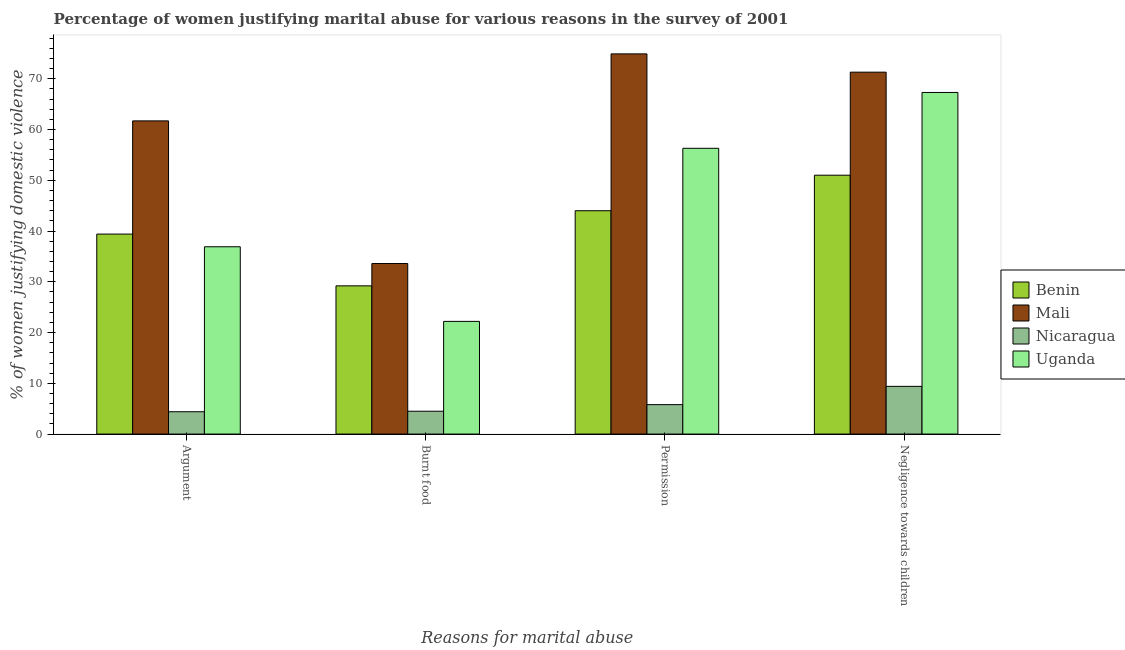How many different coloured bars are there?
Your response must be concise. 4. Are the number of bars on each tick of the X-axis equal?
Your response must be concise. Yes. How many bars are there on the 1st tick from the left?
Keep it short and to the point. 4. How many bars are there on the 4th tick from the right?
Offer a terse response. 4. What is the label of the 4th group of bars from the left?
Your answer should be very brief. Negligence towards children. Across all countries, what is the maximum percentage of women justifying abuse in the case of an argument?
Keep it short and to the point. 61.7. Across all countries, what is the minimum percentage of women justifying abuse for going without permission?
Give a very brief answer. 5.8. In which country was the percentage of women justifying abuse for burning food maximum?
Make the answer very short. Mali. In which country was the percentage of women justifying abuse for burning food minimum?
Ensure brevity in your answer.  Nicaragua. What is the total percentage of women justifying abuse in the case of an argument in the graph?
Give a very brief answer. 142.4. What is the difference between the percentage of women justifying abuse for going without permission in Mali and the percentage of women justifying abuse for showing negligence towards children in Nicaragua?
Your answer should be compact. 65.5. What is the average percentage of women justifying abuse for showing negligence towards children per country?
Keep it short and to the point. 49.75. What is the difference between the percentage of women justifying abuse for going without permission and percentage of women justifying abuse in the case of an argument in Uganda?
Your answer should be compact. 19.4. What is the ratio of the percentage of women justifying abuse for burning food in Uganda to that in Benin?
Offer a very short reply. 0.76. Is the percentage of women justifying abuse in the case of an argument in Benin less than that in Nicaragua?
Offer a very short reply. No. What is the difference between the highest and the second highest percentage of women justifying abuse for going without permission?
Your answer should be compact. 18.6. What is the difference between the highest and the lowest percentage of women justifying abuse for showing negligence towards children?
Provide a succinct answer. 61.9. Is it the case that in every country, the sum of the percentage of women justifying abuse for going without permission and percentage of women justifying abuse for showing negligence towards children is greater than the sum of percentage of women justifying abuse in the case of an argument and percentage of women justifying abuse for burning food?
Provide a short and direct response. No. What does the 3rd bar from the left in Permission represents?
Your response must be concise. Nicaragua. What does the 1st bar from the right in Argument represents?
Keep it short and to the point. Uganda. Is it the case that in every country, the sum of the percentage of women justifying abuse in the case of an argument and percentage of women justifying abuse for burning food is greater than the percentage of women justifying abuse for going without permission?
Provide a succinct answer. Yes. Are all the bars in the graph horizontal?
Make the answer very short. No. Are the values on the major ticks of Y-axis written in scientific E-notation?
Provide a succinct answer. No. How are the legend labels stacked?
Give a very brief answer. Vertical. What is the title of the graph?
Offer a terse response. Percentage of women justifying marital abuse for various reasons in the survey of 2001. What is the label or title of the X-axis?
Your response must be concise. Reasons for marital abuse. What is the label or title of the Y-axis?
Provide a short and direct response. % of women justifying domestic violence. What is the % of women justifying domestic violence of Benin in Argument?
Provide a succinct answer. 39.4. What is the % of women justifying domestic violence of Mali in Argument?
Your answer should be compact. 61.7. What is the % of women justifying domestic violence of Uganda in Argument?
Offer a terse response. 36.9. What is the % of women justifying domestic violence in Benin in Burnt food?
Your answer should be very brief. 29.2. What is the % of women justifying domestic violence of Mali in Burnt food?
Your answer should be very brief. 33.6. What is the % of women justifying domestic violence in Uganda in Burnt food?
Your answer should be very brief. 22.2. What is the % of women justifying domestic violence of Mali in Permission?
Your response must be concise. 74.9. What is the % of women justifying domestic violence in Uganda in Permission?
Ensure brevity in your answer.  56.3. What is the % of women justifying domestic violence in Benin in Negligence towards children?
Provide a succinct answer. 51. What is the % of women justifying domestic violence in Mali in Negligence towards children?
Offer a terse response. 71.3. What is the % of women justifying domestic violence in Nicaragua in Negligence towards children?
Offer a terse response. 9.4. What is the % of women justifying domestic violence in Uganda in Negligence towards children?
Your answer should be very brief. 67.3. Across all Reasons for marital abuse, what is the maximum % of women justifying domestic violence of Mali?
Offer a very short reply. 74.9. Across all Reasons for marital abuse, what is the maximum % of women justifying domestic violence in Uganda?
Provide a short and direct response. 67.3. Across all Reasons for marital abuse, what is the minimum % of women justifying domestic violence of Benin?
Your answer should be compact. 29.2. Across all Reasons for marital abuse, what is the minimum % of women justifying domestic violence in Mali?
Ensure brevity in your answer.  33.6. Across all Reasons for marital abuse, what is the minimum % of women justifying domestic violence in Uganda?
Provide a short and direct response. 22.2. What is the total % of women justifying domestic violence in Benin in the graph?
Provide a succinct answer. 163.6. What is the total % of women justifying domestic violence in Mali in the graph?
Offer a terse response. 241.5. What is the total % of women justifying domestic violence in Nicaragua in the graph?
Make the answer very short. 24.1. What is the total % of women justifying domestic violence in Uganda in the graph?
Your answer should be very brief. 182.7. What is the difference between the % of women justifying domestic violence in Benin in Argument and that in Burnt food?
Your response must be concise. 10.2. What is the difference between the % of women justifying domestic violence of Mali in Argument and that in Burnt food?
Ensure brevity in your answer.  28.1. What is the difference between the % of women justifying domestic violence in Nicaragua in Argument and that in Burnt food?
Provide a short and direct response. -0.1. What is the difference between the % of women justifying domestic violence in Uganda in Argument and that in Burnt food?
Your answer should be compact. 14.7. What is the difference between the % of women justifying domestic violence in Benin in Argument and that in Permission?
Provide a short and direct response. -4.6. What is the difference between the % of women justifying domestic violence in Nicaragua in Argument and that in Permission?
Keep it short and to the point. -1.4. What is the difference between the % of women justifying domestic violence of Uganda in Argument and that in Permission?
Make the answer very short. -19.4. What is the difference between the % of women justifying domestic violence in Mali in Argument and that in Negligence towards children?
Provide a short and direct response. -9.6. What is the difference between the % of women justifying domestic violence in Uganda in Argument and that in Negligence towards children?
Your response must be concise. -30.4. What is the difference between the % of women justifying domestic violence of Benin in Burnt food and that in Permission?
Provide a short and direct response. -14.8. What is the difference between the % of women justifying domestic violence in Mali in Burnt food and that in Permission?
Make the answer very short. -41.3. What is the difference between the % of women justifying domestic violence in Uganda in Burnt food and that in Permission?
Give a very brief answer. -34.1. What is the difference between the % of women justifying domestic violence in Benin in Burnt food and that in Negligence towards children?
Provide a short and direct response. -21.8. What is the difference between the % of women justifying domestic violence in Mali in Burnt food and that in Negligence towards children?
Provide a succinct answer. -37.7. What is the difference between the % of women justifying domestic violence in Uganda in Burnt food and that in Negligence towards children?
Give a very brief answer. -45.1. What is the difference between the % of women justifying domestic violence of Mali in Permission and that in Negligence towards children?
Your response must be concise. 3.6. What is the difference between the % of women justifying domestic violence in Nicaragua in Permission and that in Negligence towards children?
Provide a succinct answer. -3.6. What is the difference between the % of women justifying domestic violence in Uganda in Permission and that in Negligence towards children?
Your response must be concise. -11. What is the difference between the % of women justifying domestic violence of Benin in Argument and the % of women justifying domestic violence of Nicaragua in Burnt food?
Offer a terse response. 34.9. What is the difference between the % of women justifying domestic violence of Mali in Argument and the % of women justifying domestic violence of Nicaragua in Burnt food?
Provide a short and direct response. 57.2. What is the difference between the % of women justifying domestic violence of Mali in Argument and the % of women justifying domestic violence of Uganda in Burnt food?
Ensure brevity in your answer.  39.5. What is the difference between the % of women justifying domestic violence of Nicaragua in Argument and the % of women justifying domestic violence of Uganda in Burnt food?
Give a very brief answer. -17.8. What is the difference between the % of women justifying domestic violence of Benin in Argument and the % of women justifying domestic violence of Mali in Permission?
Provide a short and direct response. -35.5. What is the difference between the % of women justifying domestic violence in Benin in Argument and the % of women justifying domestic violence in Nicaragua in Permission?
Give a very brief answer. 33.6. What is the difference between the % of women justifying domestic violence of Benin in Argument and the % of women justifying domestic violence of Uganda in Permission?
Provide a succinct answer. -16.9. What is the difference between the % of women justifying domestic violence in Mali in Argument and the % of women justifying domestic violence in Nicaragua in Permission?
Keep it short and to the point. 55.9. What is the difference between the % of women justifying domestic violence of Mali in Argument and the % of women justifying domestic violence of Uganda in Permission?
Offer a terse response. 5.4. What is the difference between the % of women justifying domestic violence in Nicaragua in Argument and the % of women justifying domestic violence in Uganda in Permission?
Your response must be concise. -51.9. What is the difference between the % of women justifying domestic violence in Benin in Argument and the % of women justifying domestic violence in Mali in Negligence towards children?
Your answer should be compact. -31.9. What is the difference between the % of women justifying domestic violence of Benin in Argument and the % of women justifying domestic violence of Uganda in Negligence towards children?
Your answer should be very brief. -27.9. What is the difference between the % of women justifying domestic violence of Mali in Argument and the % of women justifying domestic violence of Nicaragua in Negligence towards children?
Provide a succinct answer. 52.3. What is the difference between the % of women justifying domestic violence of Nicaragua in Argument and the % of women justifying domestic violence of Uganda in Negligence towards children?
Your answer should be compact. -62.9. What is the difference between the % of women justifying domestic violence in Benin in Burnt food and the % of women justifying domestic violence in Mali in Permission?
Provide a succinct answer. -45.7. What is the difference between the % of women justifying domestic violence in Benin in Burnt food and the % of women justifying domestic violence in Nicaragua in Permission?
Provide a short and direct response. 23.4. What is the difference between the % of women justifying domestic violence of Benin in Burnt food and the % of women justifying domestic violence of Uganda in Permission?
Give a very brief answer. -27.1. What is the difference between the % of women justifying domestic violence in Mali in Burnt food and the % of women justifying domestic violence in Nicaragua in Permission?
Provide a succinct answer. 27.8. What is the difference between the % of women justifying domestic violence in Mali in Burnt food and the % of women justifying domestic violence in Uganda in Permission?
Your answer should be very brief. -22.7. What is the difference between the % of women justifying domestic violence of Nicaragua in Burnt food and the % of women justifying domestic violence of Uganda in Permission?
Ensure brevity in your answer.  -51.8. What is the difference between the % of women justifying domestic violence in Benin in Burnt food and the % of women justifying domestic violence in Mali in Negligence towards children?
Your answer should be compact. -42.1. What is the difference between the % of women justifying domestic violence in Benin in Burnt food and the % of women justifying domestic violence in Nicaragua in Negligence towards children?
Keep it short and to the point. 19.8. What is the difference between the % of women justifying domestic violence of Benin in Burnt food and the % of women justifying domestic violence of Uganda in Negligence towards children?
Make the answer very short. -38.1. What is the difference between the % of women justifying domestic violence of Mali in Burnt food and the % of women justifying domestic violence of Nicaragua in Negligence towards children?
Your answer should be very brief. 24.2. What is the difference between the % of women justifying domestic violence in Mali in Burnt food and the % of women justifying domestic violence in Uganda in Negligence towards children?
Offer a terse response. -33.7. What is the difference between the % of women justifying domestic violence in Nicaragua in Burnt food and the % of women justifying domestic violence in Uganda in Negligence towards children?
Give a very brief answer. -62.8. What is the difference between the % of women justifying domestic violence of Benin in Permission and the % of women justifying domestic violence of Mali in Negligence towards children?
Your response must be concise. -27.3. What is the difference between the % of women justifying domestic violence in Benin in Permission and the % of women justifying domestic violence in Nicaragua in Negligence towards children?
Make the answer very short. 34.6. What is the difference between the % of women justifying domestic violence in Benin in Permission and the % of women justifying domestic violence in Uganda in Negligence towards children?
Offer a very short reply. -23.3. What is the difference between the % of women justifying domestic violence in Mali in Permission and the % of women justifying domestic violence in Nicaragua in Negligence towards children?
Your response must be concise. 65.5. What is the difference between the % of women justifying domestic violence in Nicaragua in Permission and the % of women justifying domestic violence in Uganda in Negligence towards children?
Provide a short and direct response. -61.5. What is the average % of women justifying domestic violence in Benin per Reasons for marital abuse?
Make the answer very short. 40.9. What is the average % of women justifying domestic violence of Mali per Reasons for marital abuse?
Provide a short and direct response. 60.38. What is the average % of women justifying domestic violence of Nicaragua per Reasons for marital abuse?
Your response must be concise. 6.03. What is the average % of women justifying domestic violence in Uganda per Reasons for marital abuse?
Provide a succinct answer. 45.67. What is the difference between the % of women justifying domestic violence in Benin and % of women justifying domestic violence in Mali in Argument?
Make the answer very short. -22.3. What is the difference between the % of women justifying domestic violence of Benin and % of women justifying domestic violence of Nicaragua in Argument?
Offer a very short reply. 35. What is the difference between the % of women justifying domestic violence in Benin and % of women justifying domestic violence in Uganda in Argument?
Make the answer very short. 2.5. What is the difference between the % of women justifying domestic violence in Mali and % of women justifying domestic violence in Nicaragua in Argument?
Ensure brevity in your answer.  57.3. What is the difference between the % of women justifying domestic violence in Mali and % of women justifying domestic violence in Uganda in Argument?
Your response must be concise. 24.8. What is the difference between the % of women justifying domestic violence in Nicaragua and % of women justifying domestic violence in Uganda in Argument?
Ensure brevity in your answer.  -32.5. What is the difference between the % of women justifying domestic violence in Benin and % of women justifying domestic violence in Mali in Burnt food?
Your answer should be very brief. -4.4. What is the difference between the % of women justifying domestic violence of Benin and % of women justifying domestic violence of Nicaragua in Burnt food?
Your response must be concise. 24.7. What is the difference between the % of women justifying domestic violence in Benin and % of women justifying domestic violence in Uganda in Burnt food?
Your response must be concise. 7. What is the difference between the % of women justifying domestic violence in Mali and % of women justifying domestic violence in Nicaragua in Burnt food?
Provide a short and direct response. 29.1. What is the difference between the % of women justifying domestic violence in Nicaragua and % of women justifying domestic violence in Uganda in Burnt food?
Make the answer very short. -17.7. What is the difference between the % of women justifying domestic violence in Benin and % of women justifying domestic violence in Mali in Permission?
Keep it short and to the point. -30.9. What is the difference between the % of women justifying domestic violence in Benin and % of women justifying domestic violence in Nicaragua in Permission?
Your answer should be compact. 38.2. What is the difference between the % of women justifying domestic violence in Benin and % of women justifying domestic violence in Uganda in Permission?
Keep it short and to the point. -12.3. What is the difference between the % of women justifying domestic violence in Mali and % of women justifying domestic violence in Nicaragua in Permission?
Ensure brevity in your answer.  69.1. What is the difference between the % of women justifying domestic violence in Nicaragua and % of women justifying domestic violence in Uganda in Permission?
Keep it short and to the point. -50.5. What is the difference between the % of women justifying domestic violence of Benin and % of women justifying domestic violence of Mali in Negligence towards children?
Provide a succinct answer. -20.3. What is the difference between the % of women justifying domestic violence of Benin and % of women justifying domestic violence of Nicaragua in Negligence towards children?
Your response must be concise. 41.6. What is the difference between the % of women justifying domestic violence of Benin and % of women justifying domestic violence of Uganda in Negligence towards children?
Keep it short and to the point. -16.3. What is the difference between the % of women justifying domestic violence in Mali and % of women justifying domestic violence in Nicaragua in Negligence towards children?
Your answer should be compact. 61.9. What is the difference between the % of women justifying domestic violence of Nicaragua and % of women justifying domestic violence of Uganda in Negligence towards children?
Your answer should be very brief. -57.9. What is the ratio of the % of women justifying domestic violence of Benin in Argument to that in Burnt food?
Offer a very short reply. 1.35. What is the ratio of the % of women justifying domestic violence in Mali in Argument to that in Burnt food?
Give a very brief answer. 1.84. What is the ratio of the % of women justifying domestic violence in Nicaragua in Argument to that in Burnt food?
Offer a very short reply. 0.98. What is the ratio of the % of women justifying domestic violence of Uganda in Argument to that in Burnt food?
Your answer should be very brief. 1.66. What is the ratio of the % of women justifying domestic violence in Benin in Argument to that in Permission?
Give a very brief answer. 0.9. What is the ratio of the % of women justifying domestic violence in Mali in Argument to that in Permission?
Your answer should be compact. 0.82. What is the ratio of the % of women justifying domestic violence of Nicaragua in Argument to that in Permission?
Your answer should be very brief. 0.76. What is the ratio of the % of women justifying domestic violence in Uganda in Argument to that in Permission?
Give a very brief answer. 0.66. What is the ratio of the % of women justifying domestic violence of Benin in Argument to that in Negligence towards children?
Make the answer very short. 0.77. What is the ratio of the % of women justifying domestic violence of Mali in Argument to that in Negligence towards children?
Your answer should be compact. 0.87. What is the ratio of the % of women justifying domestic violence of Nicaragua in Argument to that in Negligence towards children?
Offer a terse response. 0.47. What is the ratio of the % of women justifying domestic violence of Uganda in Argument to that in Negligence towards children?
Provide a succinct answer. 0.55. What is the ratio of the % of women justifying domestic violence in Benin in Burnt food to that in Permission?
Your response must be concise. 0.66. What is the ratio of the % of women justifying domestic violence of Mali in Burnt food to that in Permission?
Provide a succinct answer. 0.45. What is the ratio of the % of women justifying domestic violence of Nicaragua in Burnt food to that in Permission?
Keep it short and to the point. 0.78. What is the ratio of the % of women justifying domestic violence of Uganda in Burnt food to that in Permission?
Offer a terse response. 0.39. What is the ratio of the % of women justifying domestic violence in Benin in Burnt food to that in Negligence towards children?
Your response must be concise. 0.57. What is the ratio of the % of women justifying domestic violence of Mali in Burnt food to that in Negligence towards children?
Give a very brief answer. 0.47. What is the ratio of the % of women justifying domestic violence in Nicaragua in Burnt food to that in Negligence towards children?
Keep it short and to the point. 0.48. What is the ratio of the % of women justifying domestic violence of Uganda in Burnt food to that in Negligence towards children?
Make the answer very short. 0.33. What is the ratio of the % of women justifying domestic violence of Benin in Permission to that in Negligence towards children?
Your response must be concise. 0.86. What is the ratio of the % of women justifying domestic violence in Mali in Permission to that in Negligence towards children?
Your answer should be very brief. 1.05. What is the ratio of the % of women justifying domestic violence of Nicaragua in Permission to that in Negligence towards children?
Offer a very short reply. 0.62. What is the ratio of the % of women justifying domestic violence in Uganda in Permission to that in Negligence towards children?
Your response must be concise. 0.84. What is the difference between the highest and the second highest % of women justifying domestic violence of Nicaragua?
Offer a very short reply. 3.6. What is the difference between the highest and the second highest % of women justifying domestic violence in Uganda?
Your response must be concise. 11. What is the difference between the highest and the lowest % of women justifying domestic violence in Benin?
Keep it short and to the point. 21.8. What is the difference between the highest and the lowest % of women justifying domestic violence in Mali?
Your answer should be very brief. 41.3. What is the difference between the highest and the lowest % of women justifying domestic violence of Uganda?
Ensure brevity in your answer.  45.1. 